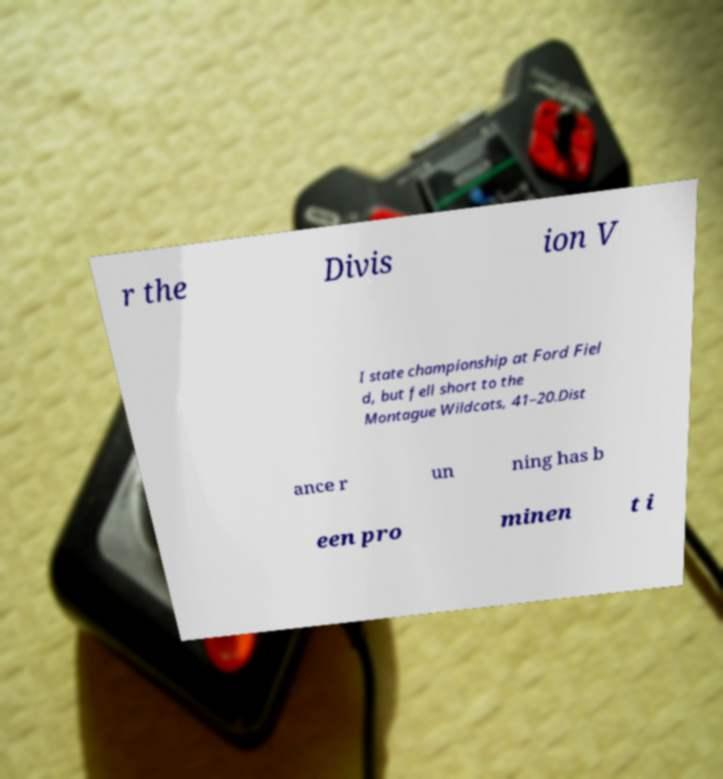Can you read and provide the text displayed in the image?This photo seems to have some interesting text. Can you extract and type it out for me? r the Divis ion V I state championship at Ford Fiel d, but fell short to the Montague Wildcats, 41–20.Dist ance r un ning has b een pro minen t i 